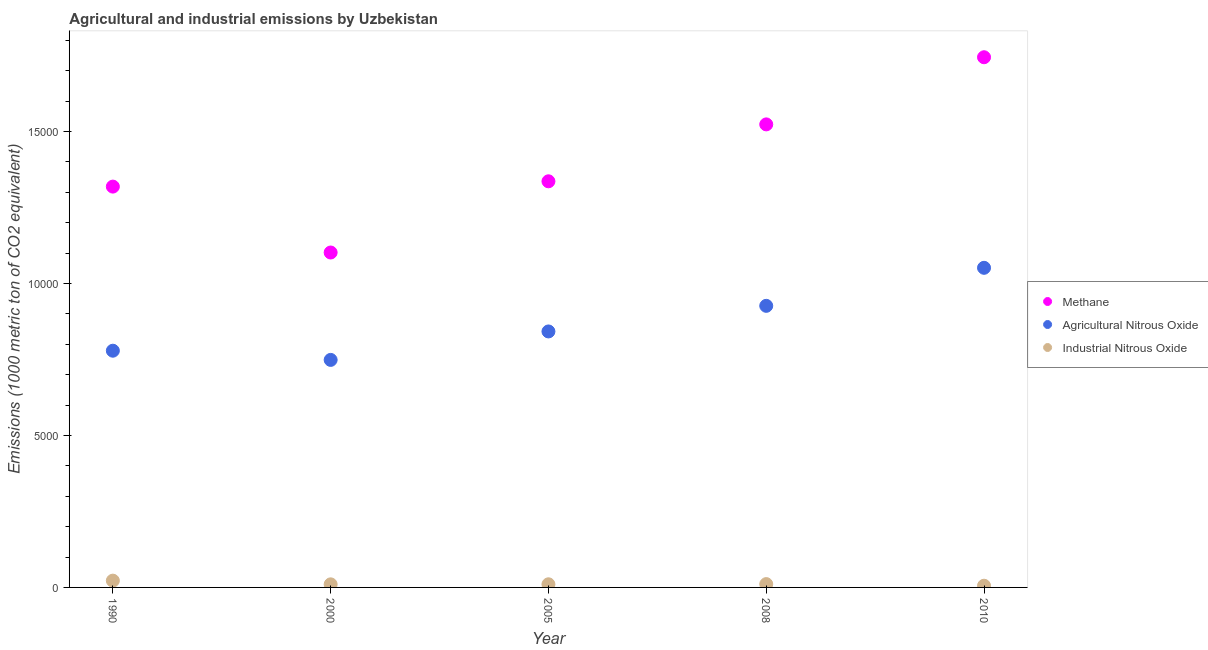How many different coloured dotlines are there?
Offer a terse response. 3. What is the amount of industrial nitrous oxide emissions in 2005?
Provide a short and direct response. 103.2. Across all years, what is the maximum amount of agricultural nitrous oxide emissions?
Your response must be concise. 1.05e+04. Across all years, what is the minimum amount of agricultural nitrous oxide emissions?
Your answer should be very brief. 7484.2. What is the total amount of methane emissions in the graph?
Make the answer very short. 7.02e+04. What is the difference between the amount of agricultural nitrous oxide emissions in 2000 and that in 2008?
Offer a terse response. -1778.3. What is the difference between the amount of industrial nitrous oxide emissions in 2005 and the amount of methane emissions in 2008?
Make the answer very short. -1.51e+04. What is the average amount of methane emissions per year?
Provide a short and direct response. 1.40e+04. In the year 2005, what is the difference between the amount of agricultural nitrous oxide emissions and amount of industrial nitrous oxide emissions?
Provide a short and direct response. 8316.9. In how many years, is the amount of industrial nitrous oxide emissions greater than 12000 metric ton?
Give a very brief answer. 0. What is the ratio of the amount of agricultural nitrous oxide emissions in 1990 to that in 2000?
Your answer should be compact. 1.04. What is the difference between the highest and the second highest amount of industrial nitrous oxide emissions?
Your answer should be very brief. 113.8. What is the difference between the highest and the lowest amount of agricultural nitrous oxide emissions?
Provide a short and direct response. 3029. In how many years, is the amount of methane emissions greater than the average amount of methane emissions taken over all years?
Make the answer very short. 2. Is the amount of agricultural nitrous oxide emissions strictly greater than the amount of methane emissions over the years?
Your answer should be very brief. No. How many dotlines are there?
Provide a succinct answer. 3. How many years are there in the graph?
Keep it short and to the point. 5. Are the values on the major ticks of Y-axis written in scientific E-notation?
Provide a succinct answer. No. Does the graph contain any zero values?
Keep it short and to the point. No. How many legend labels are there?
Provide a short and direct response. 3. What is the title of the graph?
Your response must be concise. Agricultural and industrial emissions by Uzbekistan. Does "Coal" appear as one of the legend labels in the graph?
Your response must be concise. No. What is the label or title of the Y-axis?
Give a very brief answer. Emissions (1000 metric ton of CO2 equivalent). What is the Emissions (1000 metric ton of CO2 equivalent) of Methane in 1990?
Keep it short and to the point. 1.32e+04. What is the Emissions (1000 metric ton of CO2 equivalent) of Agricultural Nitrous Oxide in 1990?
Offer a terse response. 7786.3. What is the Emissions (1000 metric ton of CO2 equivalent) in Industrial Nitrous Oxide in 1990?
Provide a short and direct response. 223.2. What is the Emissions (1000 metric ton of CO2 equivalent) of Methane in 2000?
Your response must be concise. 1.10e+04. What is the Emissions (1000 metric ton of CO2 equivalent) in Agricultural Nitrous Oxide in 2000?
Make the answer very short. 7484.2. What is the Emissions (1000 metric ton of CO2 equivalent) in Industrial Nitrous Oxide in 2000?
Ensure brevity in your answer.  101.6. What is the Emissions (1000 metric ton of CO2 equivalent) of Methane in 2005?
Provide a succinct answer. 1.34e+04. What is the Emissions (1000 metric ton of CO2 equivalent) in Agricultural Nitrous Oxide in 2005?
Ensure brevity in your answer.  8420.1. What is the Emissions (1000 metric ton of CO2 equivalent) of Industrial Nitrous Oxide in 2005?
Keep it short and to the point. 103.2. What is the Emissions (1000 metric ton of CO2 equivalent) of Methane in 2008?
Keep it short and to the point. 1.52e+04. What is the Emissions (1000 metric ton of CO2 equivalent) in Agricultural Nitrous Oxide in 2008?
Provide a succinct answer. 9262.5. What is the Emissions (1000 metric ton of CO2 equivalent) of Industrial Nitrous Oxide in 2008?
Your answer should be very brief. 109.4. What is the Emissions (1000 metric ton of CO2 equivalent) of Methane in 2010?
Provide a short and direct response. 1.74e+04. What is the Emissions (1000 metric ton of CO2 equivalent) in Agricultural Nitrous Oxide in 2010?
Provide a short and direct response. 1.05e+04. What is the Emissions (1000 metric ton of CO2 equivalent) of Industrial Nitrous Oxide in 2010?
Ensure brevity in your answer.  56.1. Across all years, what is the maximum Emissions (1000 metric ton of CO2 equivalent) in Methane?
Your answer should be compact. 1.74e+04. Across all years, what is the maximum Emissions (1000 metric ton of CO2 equivalent) in Agricultural Nitrous Oxide?
Your answer should be very brief. 1.05e+04. Across all years, what is the maximum Emissions (1000 metric ton of CO2 equivalent) of Industrial Nitrous Oxide?
Provide a succinct answer. 223.2. Across all years, what is the minimum Emissions (1000 metric ton of CO2 equivalent) of Methane?
Keep it short and to the point. 1.10e+04. Across all years, what is the minimum Emissions (1000 metric ton of CO2 equivalent) of Agricultural Nitrous Oxide?
Make the answer very short. 7484.2. Across all years, what is the minimum Emissions (1000 metric ton of CO2 equivalent) of Industrial Nitrous Oxide?
Keep it short and to the point. 56.1. What is the total Emissions (1000 metric ton of CO2 equivalent) of Methane in the graph?
Make the answer very short. 7.02e+04. What is the total Emissions (1000 metric ton of CO2 equivalent) of Agricultural Nitrous Oxide in the graph?
Your answer should be very brief. 4.35e+04. What is the total Emissions (1000 metric ton of CO2 equivalent) in Industrial Nitrous Oxide in the graph?
Provide a succinct answer. 593.5. What is the difference between the Emissions (1000 metric ton of CO2 equivalent) in Methane in 1990 and that in 2000?
Offer a terse response. 2168. What is the difference between the Emissions (1000 metric ton of CO2 equivalent) in Agricultural Nitrous Oxide in 1990 and that in 2000?
Offer a terse response. 302.1. What is the difference between the Emissions (1000 metric ton of CO2 equivalent) in Industrial Nitrous Oxide in 1990 and that in 2000?
Your response must be concise. 121.6. What is the difference between the Emissions (1000 metric ton of CO2 equivalent) of Methane in 1990 and that in 2005?
Offer a terse response. -174.6. What is the difference between the Emissions (1000 metric ton of CO2 equivalent) of Agricultural Nitrous Oxide in 1990 and that in 2005?
Provide a succinct answer. -633.8. What is the difference between the Emissions (1000 metric ton of CO2 equivalent) in Industrial Nitrous Oxide in 1990 and that in 2005?
Offer a terse response. 120. What is the difference between the Emissions (1000 metric ton of CO2 equivalent) in Methane in 1990 and that in 2008?
Ensure brevity in your answer.  -2046.5. What is the difference between the Emissions (1000 metric ton of CO2 equivalent) in Agricultural Nitrous Oxide in 1990 and that in 2008?
Make the answer very short. -1476.2. What is the difference between the Emissions (1000 metric ton of CO2 equivalent) in Industrial Nitrous Oxide in 1990 and that in 2008?
Make the answer very short. 113.8. What is the difference between the Emissions (1000 metric ton of CO2 equivalent) in Methane in 1990 and that in 2010?
Your answer should be very brief. -4255. What is the difference between the Emissions (1000 metric ton of CO2 equivalent) of Agricultural Nitrous Oxide in 1990 and that in 2010?
Provide a short and direct response. -2726.9. What is the difference between the Emissions (1000 metric ton of CO2 equivalent) of Industrial Nitrous Oxide in 1990 and that in 2010?
Provide a short and direct response. 167.1. What is the difference between the Emissions (1000 metric ton of CO2 equivalent) in Methane in 2000 and that in 2005?
Provide a short and direct response. -2342.6. What is the difference between the Emissions (1000 metric ton of CO2 equivalent) of Agricultural Nitrous Oxide in 2000 and that in 2005?
Ensure brevity in your answer.  -935.9. What is the difference between the Emissions (1000 metric ton of CO2 equivalent) in Industrial Nitrous Oxide in 2000 and that in 2005?
Offer a very short reply. -1.6. What is the difference between the Emissions (1000 metric ton of CO2 equivalent) in Methane in 2000 and that in 2008?
Your response must be concise. -4214.5. What is the difference between the Emissions (1000 metric ton of CO2 equivalent) in Agricultural Nitrous Oxide in 2000 and that in 2008?
Offer a terse response. -1778.3. What is the difference between the Emissions (1000 metric ton of CO2 equivalent) in Industrial Nitrous Oxide in 2000 and that in 2008?
Make the answer very short. -7.8. What is the difference between the Emissions (1000 metric ton of CO2 equivalent) in Methane in 2000 and that in 2010?
Offer a very short reply. -6423. What is the difference between the Emissions (1000 metric ton of CO2 equivalent) in Agricultural Nitrous Oxide in 2000 and that in 2010?
Provide a succinct answer. -3029. What is the difference between the Emissions (1000 metric ton of CO2 equivalent) in Industrial Nitrous Oxide in 2000 and that in 2010?
Provide a short and direct response. 45.5. What is the difference between the Emissions (1000 metric ton of CO2 equivalent) in Methane in 2005 and that in 2008?
Keep it short and to the point. -1871.9. What is the difference between the Emissions (1000 metric ton of CO2 equivalent) in Agricultural Nitrous Oxide in 2005 and that in 2008?
Your answer should be compact. -842.4. What is the difference between the Emissions (1000 metric ton of CO2 equivalent) in Methane in 2005 and that in 2010?
Your answer should be compact. -4080.4. What is the difference between the Emissions (1000 metric ton of CO2 equivalent) in Agricultural Nitrous Oxide in 2005 and that in 2010?
Your response must be concise. -2093.1. What is the difference between the Emissions (1000 metric ton of CO2 equivalent) in Industrial Nitrous Oxide in 2005 and that in 2010?
Offer a terse response. 47.1. What is the difference between the Emissions (1000 metric ton of CO2 equivalent) of Methane in 2008 and that in 2010?
Give a very brief answer. -2208.5. What is the difference between the Emissions (1000 metric ton of CO2 equivalent) in Agricultural Nitrous Oxide in 2008 and that in 2010?
Provide a succinct answer. -1250.7. What is the difference between the Emissions (1000 metric ton of CO2 equivalent) in Industrial Nitrous Oxide in 2008 and that in 2010?
Your answer should be very brief. 53.3. What is the difference between the Emissions (1000 metric ton of CO2 equivalent) in Methane in 1990 and the Emissions (1000 metric ton of CO2 equivalent) in Agricultural Nitrous Oxide in 2000?
Offer a very short reply. 5700.2. What is the difference between the Emissions (1000 metric ton of CO2 equivalent) in Methane in 1990 and the Emissions (1000 metric ton of CO2 equivalent) in Industrial Nitrous Oxide in 2000?
Make the answer very short. 1.31e+04. What is the difference between the Emissions (1000 metric ton of CO2 equivalent) in Agricultural Nitrous Oxide in 1990 and the Emissions (1000 metric ton of CO2 equivalent) in Industrial Nitrous Oxide in 2000?
Provide a succinct answer. 7684.7. What is the difference between the Emissions (1000 metric ton of CO2 equivalent) of Methane in 1990 and the Emissions (1000 metric ton of CO2 equivalent) of Agricultural Nitrous Oxide in 2005?
Give a very brief answer. 4764.3. What is the difference between the Emissions (1000 metric ton of CO2 equivalent) in Methane in 1990 and the Emissions (1000 metric ton of CO2 equivalent) in Industrial Nitrous Oxide in 2005?
Give a very brief answer. 1.31e+04. What is the difference between the Emissions (1000 metric ton of CO2 equivalent) in Agricultural Nitrous Oxide in 1990 and the Emissions (1000 metric ton of CO2 equivalent) in Industrial Nitrous Oxide in 2005?
Provide a short and direct response. 7683.1. What is the difference between the Emissions (1000 metric ton of CO2 equivalent) of Methane in 1990 and the Emissions (1000 metric ton of CO2 equivalent) of Agricultural Nitrous Oxide in 2008?
Offer a very short reply. 3921.9. What is the difference between the Emissions (1000 metric ton of CO2 equivalent) of Methane in 1990 and the Emissions (1000 metric ton of CO2 equivalent) of Industrial Nitrous Oxide in 2008?
Keep it short and to the point. 1.31e+04. What is the difference between the Emissions (1000 metric ton of CO2 equivalent) in Agricultural Nitrous Oxide in 1990 and the Emissions (1000 metric ton of CO2 equivalent) in Industrial Nitrous Oxide in 2008?
Give a very brief answer. 7676.9. What is the difference between the Emissions (1000 metric ton of CO2 equivalent) of Methane in 1990 and the Emissions (1000 metric ton of CO2 equivalent) of Agricultural Nitrous Oxide in 2010?
Offer a terse response. 2671.2. What is the difference between the Emissions (1000 metric ton of CO2 equivalent) in Methane in 1990 and the Emissions (1000 metric ton of CO2 equivalent) in Industrial Nitrous Oxide in 2010?
Give a very brief answer. 1.31e+04. What is the difference between the Emissions (1000 metric ton of CO2 equivalent) in Agricultural Nitrous Oxide in 1990 and the Emissions (1000 metric ton of CO2 equivalent) in Industrial Nitrous Oxide in 2010?
Your response must be concise. 7730.2. What is the difference between the Emissions (1000 metric ton of CO2 equivalent) of Methane in 2000 and the Emissions (1000 metric ton of CO2 equivalent) of Agricultural Nitrous Oxide in 2005?
Offer a very short reply. 2596.3. What is the difference between the Emissions (1000 metric ton of CO2 equivalent) in Methane in 2000 and the Emissions (1000 metric ton of CO2 equivalent) in Industrial Nitrous Oxide in 2005?
Your response must be concise. 1.09e+04. What is the difference between the Emissions (1000 metric ton of CO2 equivalent) in Agricultural Nitrous Oxide in 2000 and the Emissions (1000 metric ton of CO2 equivalent) in Industrial Nitrous Oxide in 2005?
Your answer should be very brief. 7381. What is the difference between the Emissions (1000 metric ton of CO2 equivalent) of Methane in 2000 and the Emissions (1000 metric ton of CO2 equivalent) of Agricultural Nitrous Oxide in 2008?
Offer a very short reply. 1753.9. What is the difference between the Emissions (1000 metric ton of CO2 equivalent) of Methane in 2000 and the Emissions (1000 metric ton of CO2 equivalent) of Industrial Nitrous Oxide in 2008?
Provide a succinct answer. 1.09e+04. What is the difference between the Emissions (1000 metric ton of CO2 equivalent) of Agricultural Nitrous Oxide in 2000 and the Emissions (1000 metric ton of CO2 equivalent) of Industrial Nitrous Oxide in 2008?
Keep it short and to the point. 7374.8. What is the difference between the Emissions (1000 metric ton of CO2 equivalent) in Methane in 2000 and the Emissions (1000 metric ton of CO2 equivalent) in Agricultural Nitrous Oxide in 2010?
Make the answer very short. 503.2. What is the difference between the Emissions (1000 metric ton of CO2 equivalent) in Methane in 2000 and the Emissions (1000 metric ton of CO2 equivalent) in Industrial Nitrous Oxide in 2010?
Offer a terse response. 1.10e+04. What is the difference between the Emissions (1000 metric ton of CO2 equivalent) in Agricultural Nitrous Oxide in 2000 and the Emissions (1000 metric ton of CO2 equivalent) in Industrial Nitrous Oxide in 2010?
Your response must be concise. 7428.1. What is the difference between the Emissions (1000 metric ton of CO2 equivalent) of Methane in 2005 and the Emissions (1000 metric ton of CO2 equivalent) of Agricultural Nitrous Oxide in 2008?
Make the answer very short. 4096.5. What is the difference between the Emissions (1000 metric ton of CO2 equivalent) of Methane in 2005 and the Emissions (1000 metric ton of CO2 equivalent) of Industrial Nitrous Oxide in 2008?
Make the answer very short. 1.32e+04. What is the difference between the Emissions (1000 metric ton of CO2 equivalent) in Agricultural Nitrous Oxide in 2005 and the Emissions (1000 metric ton of CO2 equivalent) in Industrial Nitrous Oxide in 2008?
Your answer should be very brief. 8310.7. What is the difference between the Emissions (1000 metric ton of CO2 equivalent) in Methane in 2005 and the Emissions (1000 metric ton of CO2 equivalent) in Agricultural Nitrous Oxide in 2010?
Ensure brevity in your answer.  2845.8. What is the difference between the Emissions (1000 metric ton of CO2 equivalent) in Methane in 2005 and the Emissions (1000 metric ton of CO2 equivalent) in Industrial Nitrous Oxide in 2010?
Offer a very short reply. 1.33e+04. What is the difference between the Emissions (1000 metric ton of CO2 equivalent) in Agricultural Nitrous Oxide in 2005 and the Emissions (1000 metric ton of CO2 equivalent) in Industrial Nitrous Oxide in 2010?
Offer a very short reply. 8364. What is the difference between the Emissions (1000 metric ton of CO2 equivalent) in Methane in 2008 and the Emissions (1000 metric ton of CO2 equivalent) in Agricultural Nitrous Oxide in 2010?
Provide a short and direct response. 4717.7. What is the difference between the Emissions (1000 metric ton of CO2 equivalent) in Methane in 2008 and the Emissions (1000 metric ton of CO2 equivalent) in Industrial Nitrous Oxide in 2010?
Your answer should be very brief. 1.52e+04. What is the difference between the Emissions (1000 metric ton of CO2 equivalent) of Agricultural Nitrous Oxide in 2008 and the Emissions (1000 metric ton of CO2 equivalent) of Industrial Nitrous Oxide in 2010?
Keep it short and to the point. 9206.4. What is the average Emissions (1000 metric ton of CO2 equivalent) in Methane per year?
Ensure brevity in your answer.  1.40e+04. What is the average Emissions (1000 metric ton of CO2 equivalent) in Agricultural Nitrous Oxide per year?
Offer a terse response. 8693.26. What is the average Emissions (1000 metric ton of CO2 equivalent) of Industrial Nitrous Oxide per year?
Ensure brevity in your answer.  118.7. In the year 1990, what is the difference between the Emissions (1000 metric ton of CO2 equivalent) of Methane and Emissions (1000 metric ton of CO2 equivalent) of Agricultural Nitrous Oxide?
Offer a terse response. 5398.1. In the year 1990, what is the difference between the Emissions (1000 metric ton of CO2 equivalent) in Methane and Emissions (1000 metric ton of CO2 equivalent) in Industrial Nitrous Oxide?
Make the answer very short. 1.30e+04. In the year 1990, what is the difference between the Emissions (1000 metric ton of CO2 equivalent) in Agricultural Nitrous Oxide and Emissions (1000 metric ton of CO2 equivalent) in Industrial Nitrous Oxide?
Your answer should be compact. 7563.1. In the year 2000, what is the difference between the Emissions (1000 metric ton of CO2 equivalent) of Methane and Emissions (1000 metric ton of CO2 equivalent) of Agricultural Nitrous Oxide?
Keep it short and to the point. 3532.2. In the year 2000, what is the difference between the Emissions (1000 metric ton of CO2 equivalent) of Methane and Emissions (1000 metric ton of CO2 equivalent) of Industrial Nitrous Oxide?
Keep it short and to the point. 1.09e+04. In the year 2000, what is the difference between the Emissions (1000 metric ton of CO2 equivalent) in Agricultural Nitrous Oxide and Emissions (1000 metric ton of CO2 equivalent) in Industrial Nitrous Oxide?
Provide a succinct answer. 7382.6. In the year 2005, what is the difference between the Emissions (1000 metric ton of CO2 equivalent) of Methane and Emissions (1000 metric ton of CO2 equivalent) of Agricultural Nitrous Oxide?
Offer a very short reply. 4938.9. In the year 2005, what is the difference between the Emissions (1000 metric ton of CO2 equivalent) in Methane and Emissions (1000 metric ton of CO2 equivalent) in Industrial Nitrous Oxide?
Offer a very short reply. 1.33e+04. In the year 2005, what is the difference between the Emissions (1000 metric ton of CO2 equivalent) of Agricultural Nitrous Oxide and Emissions (1000 metric ton of CO2 equivalent) of Industrial Nitrous Oxide?
Ensure brevity in your answer.  8316.9. In the year 2008, what is the difference between the Emissions (1000 metric ton of CO2 equivalent) in Methane and Emissions (1000 metric ton of CO2 equivalent) in Agricultural Nitrous Oxide?
Keep it short and to the point. 5968.4. In the year 2008, what is the difference between the Emissions (1000 metric ton of CO2 equivalent) in Methane and Emissions (1000 metric ton of CO2 equivalent) in Industrial Nitrous Oxide?
Your answer should be very brief. 1.51e+04. In the year 2008, what is the difference between the Emissions (1000 metric ton of CO2 equivalent) in Agricultural Nitrous Oxide and Emissions (1000 metric ton of CO2 equivalent) in Industrial Nitrous Oxide?
Give a very brief answer. 9153.1. In the year 2010, what is the difference between the Emissions (1000 metric ton of CO2 equivalent) in Methane and Emissions (1000 metric ton of CO2 equivalent) in Agricultural Nitrous Oxide?
Provide a short and direct response. 6926.2. In the year 2010, what is the difference between the Emissions (1000 metric ton of CO2 equivalent) of Methane and Emissions (1000 metric ton of CO2 equivalent) of Industrial Nitrous Oxide?
Your answer should be very brief. 1.74e+04. In the year 2010, what is the difference between the Emissions (1000 metric ton of CO2 equivalent) of Agricultural Nitrous Oxide and Emissions (1000 metric ton of CO2 equivalent) of Industrial Nitrous Oxide?
Ensure brevity in your answer.  1.05e+04. What is the ratio of the Emissions (1000 metric ton of CO2 equivalent) in Methane in 1990 to that in 2000?
Offer a terse response. 1.2. What is the ratio of the Emissions (1000 metric ton of CO2 equivalent) in Agricultural Nitrous Oxide in 1990 to that in 2000?
Your response must be concise. 1.04. What is the ratio of the Emissions (1000 metric ton of CO2 equivalent) of Industrial Nitrous Oxide in 1990 to that in 2000?
Offer a terse response. 2.2. What is the ratio of the Emissions (1000 metric ton of CO2 equivalent) in Methane in 1990 to that in 2005?
Keep it short and to the point. 0.99. What is the ratio of the Emissions (1000 metric ton of CO2 equivalent) of Agricultural Nitrous Oxide in 1990 to that in 2005?
Keep it short and to the point. 0.92. What is the ratio of the Emissions (1000 metric ton of CO2 equivalent) of Industrial Nitrous Oxide in 1990 to that in 2005?
Your response must be concise. 2.16. What is the ratio of the Emissions (1000 metric ton of CO2 equivalent) in Methane in 1990 to that in 2008?
Provide a succinct answer. 0.87. What is the ratio of the Emissions (1000 metric ton of CO2 equivalent) of Agricultural Nitrous Oxide in 1990 to that in 2008?
Give a very brief answer. 0.84. What is the ratio of the Emissions (1000 metric ton of CO2 equivalent) of Industrial Nitrous Oxide in 1990 to that in 2008?
Provide a short and direct response. 2.04. What is the ratio of the Emissions (1000 metric ton of CO2 equivalent) of Methane in 1990 to that in 2010?
Keep it short and to the point. 0.76. What is the ratio of the Emissions (1000 metric ton of CO2 equivalent) in Agricultural Nitrous Oxide in 1990 to that in 2010?
Give a very brief answer. 0.74. What is the ratio of the Emissions (1000 metric ton of CO2 equivalent) in Industrial Nitrous Oxide in 1990 to that in 2010?
Your answer should be very brief. 3.98. What is the ratio of the Emissions (1000 metric ton of CO2 equivalent) of Methane in 2000 to that in 2005?
Your answer should be very brief. 0.82. What is the ratio of the Emissions (1000 metric ton of CO2 equivalent) of Agricultural Nitrous Oxide in 2000 to that in 2005?
Give a very brief answer. 0.89. What is the ratio of the Emissions (1000 metric ton of CO2 equivalent) in Industrial Nitrous Oxide in 2000 to that in 2005?
Keep it short and to the point. 0.98. What is the ratio of the Emissions (1000 metric ton of CO2 equivalent) of Methane in 2000 to that in 2008?
Provide a succinct answer. 0.72. What is the ratio of the Emissions (1000 metric ton of CO2 equivalent) in Agricultural Nitrous Oxide in 2000 to that in 2008?
Your answer should be very brief. 0.81. What is the ratio of the Emissions (1000 metric ton of CO2 equivalent) in Industrial Nitrous Oxide in 2000 to that in 2008?
Provide a short and direct response. 0.93. What is the ratio of the Emissions (1000 metric ton of CO2 equivalent) of Methane in 2000 to that in 2010?
Offer a terse response. 0.63. What is the ratio of the Emissions (1000 metric ton of CO2 equivalent) in Agricultural Nitrous Oxide in 2000 to that in 2010?
Make the answer very short. 0.71. What is the ratio of the Emissions (1000 metric ton of CO2 equivalent) of Industrial Nitrous Oxide in 2000 to that in 2010?
Give a very brief answer. 1.81. What is the ratio of the Emissions (1000 metric ton of CO2 equivalent) in Methane in 2005 to that in 2008?
Offer a very short reply. 0.88. What is the ratio of the Emissions (1000 metric ton of CO2 equivalent) in Industrial Nitrous Oxide in 2005 to that in 2008?
Ensure brevity in your answer.  0.94. What is the ratio of the Emissions (1000 metric ton of CO2 equivalent) of Methane in 2005 to that in 2010?
Your response must be concise. 0.77. What is the ratio of the Emissions (1000 metric ton of CO2 equivalent) in Agricultural Nitrous Oxide in 2005 to that in 2010?
Your answer should be compact. 0.8. What is the ratio of the Emissions (1000 metric ton of CO2 equivalent) of Industrial Nitrous Oxide in 2005 to that in 2010?
Provide a succinct answer. 1.84. What is the ratio of the Emissions (1000 metric ton of CO2 equivalent) in Methane in 2008 to that in 2010?
Your response must be concise. 0.87. What is the ratio of the Emissions (1000 metric ton of CO2 equivalent) of Agricultural Nitrous Oxide in 2008 to that in 2010?
Make the answer very short. 0.88. What is the ratio of the Emissions (1000 metric ton of CO2 equivalent) of Industrial Nitrous Oxide in 2008 to that in 2010?
Make the answer very short. 1.95. What is the difference between the highest and the second highest Emissions (1000 metric ton of CO2 equivalent) of Methane?
Provide a succinct answer. 2208.5. What is the difference between the highest and the second highest Emissions (1000 metric ton of CO2 equivalent) in Agricultural Nitrous Oxide?
Ensure brevity in your answer.  1250.7. What is the difference between the highest and the second highest Emissions (1000 metric ton of CO2 equivalent) in Industrial Nitrous Oxide?
Your answer should be very brief. 113.8. What is the difference between the highest and the lowest Emissions (1000 metric ton of CO2 equivalent) in Methane?
Ensure brevity in your answer.  6423. What is the difference between the highest and the lowest Emissions (1000 metric ton of CO2 equivalent) in Agricultural Nitrous Oxide?
Your response must be concise. 3029. What is the difference between the highest and the lowest Emissions (1000 metric ton of CO2 equivalent) of Industrial Nitrous Oxide?
Make the answer very short. 167.1. 